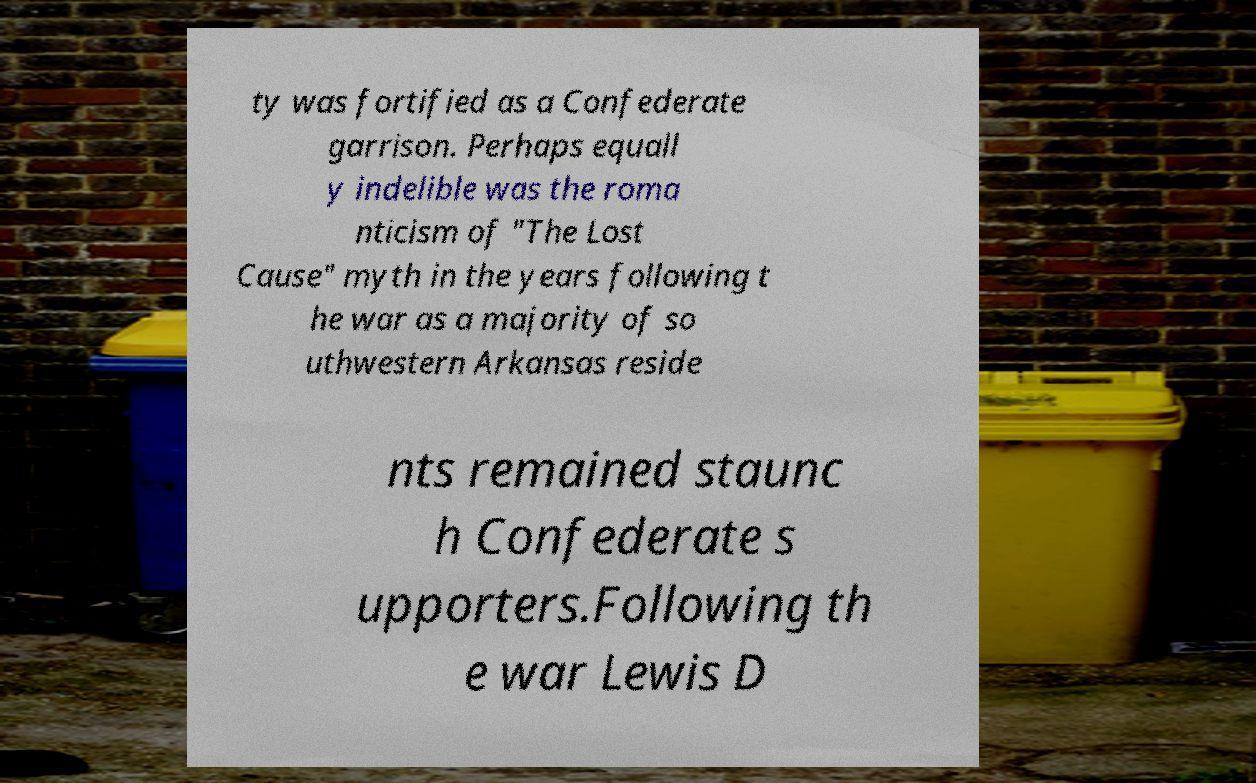Can you accurately transcribe the text from the provided image for me? ty was fortified as a Confederate garrison. Perhaps equall y indelible was the roma nticism of "The Lost Cause" myth in the years following t he war as a majority of so uthwestern Arkansas reside nts remained staunc h Confederate s upporters.Following th e war Lewis D 